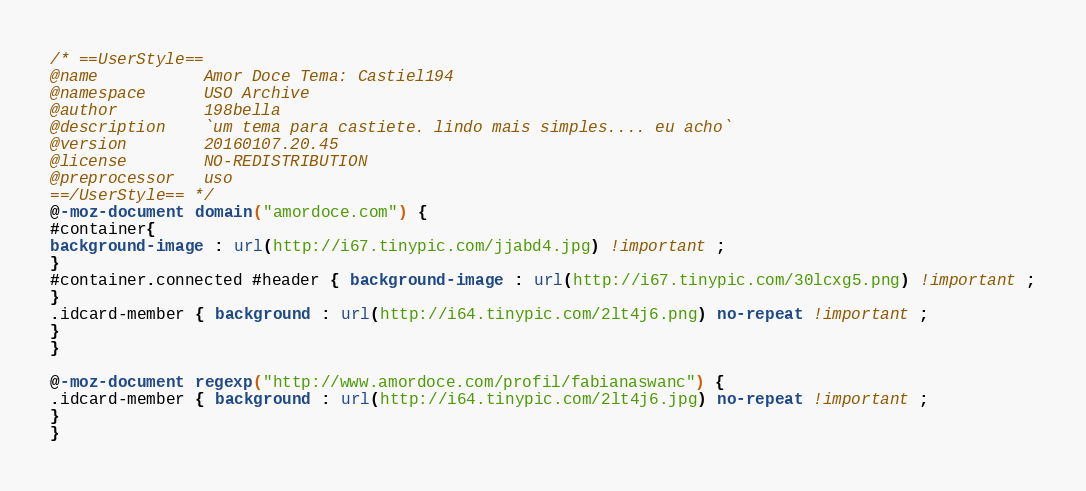Convert code to text. <code><loc_0><loc_0><loc_500><loc_500><_CSS_>/* ==UserStyle==
@name           Amor Doce Tema: Castiel194
@namespace      USO Archive
@author         198bella
@description    `um tema para castiete. lindo mais simples.... eu acho`
@version        20160107.20.45
@license        NO-REDISTRIBUTION
@preprocessor   uso
==/UserStyle== */
@-moz-document domain("amordoce.com") {
#container{
background-image : url(http://i67.tinypic.com/jjabd4.jpg) !important ;
}
#container.connected #header { background-image : url(http://i67.tinypic.com/30lcxg5.png) !important ;
}
.idcard-member { background : url(http://i64.tinypic.com/2lt4j6.png) no-repeat !important ;
}
}

@-moz-document regexp("http://www.amordoce.com/profil/fabianaswanc") {
.idcard-member { background : url(http://i64.tinypic.com/2lt4j6.jpg) no-repeat !important ;
}
}</code> 